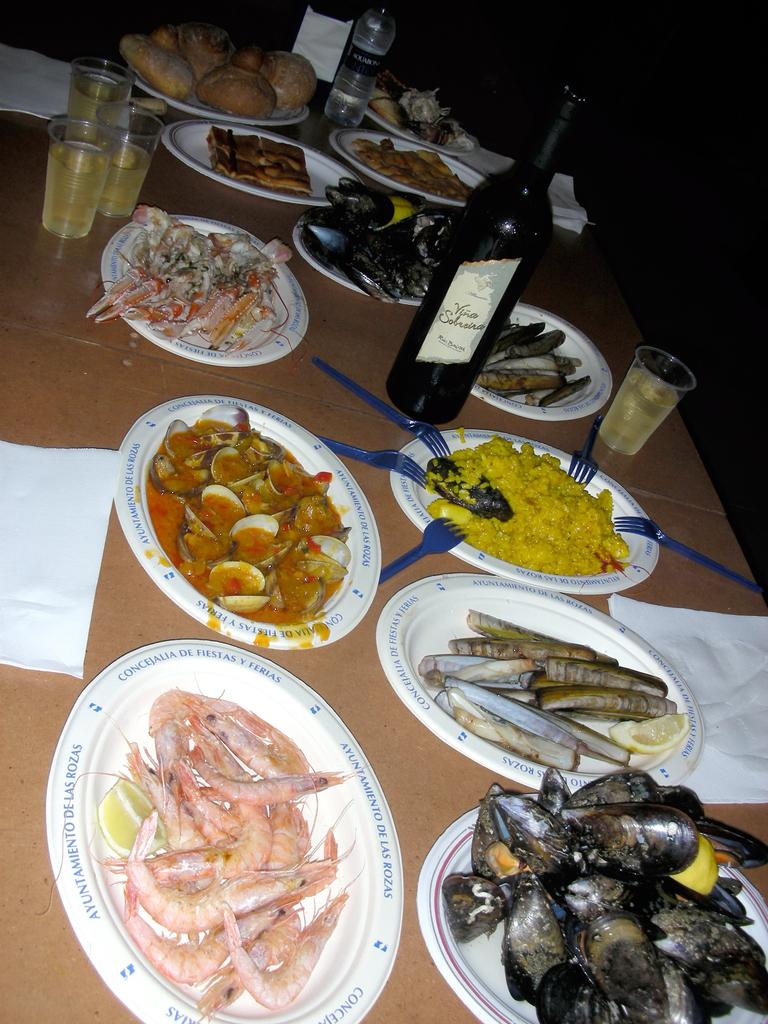What type of furniture is present in the image? There is a table in the image. What items can be seen on the table? Tissues, bottles, glasses, plates, prawns, shells, and forks are visible on the table. What food items are on the plates? Prawns, shells, and other food items are on the plates. What utensils are present on the plates? Forks are present on the plates. What type of amusement can be seen on the table in the image? There is no amusement present on the table in the image. What type of cup is visible on the table in the image? There is no cup visible on the table in the image. 